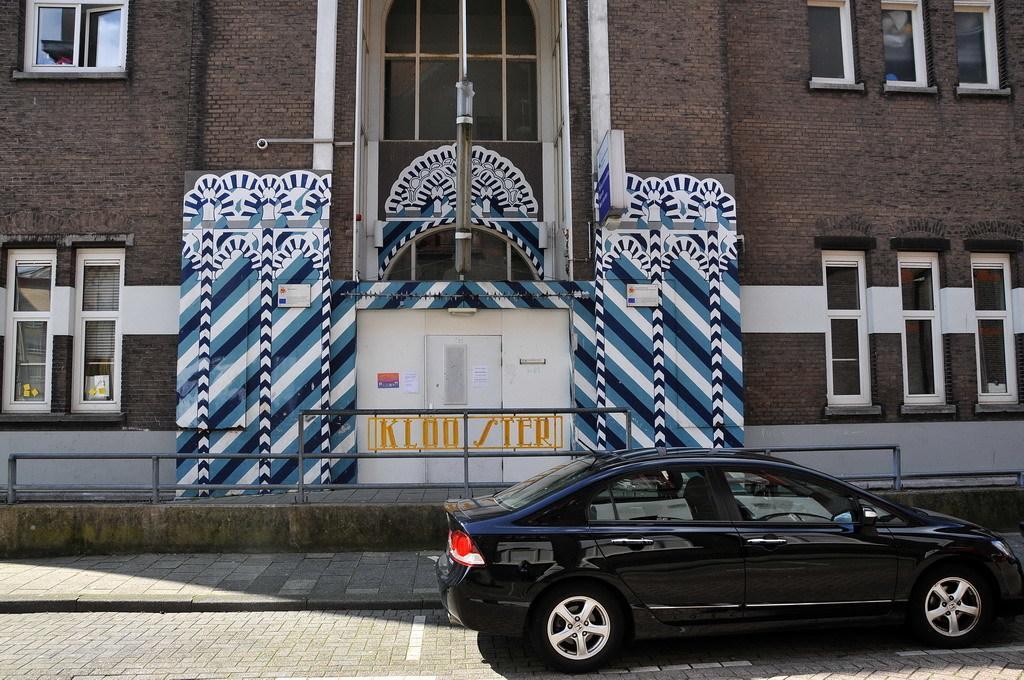Please provide a concise description of this image. In this picture we can see a black color car in the front, in the background there is a building, we can see windows and a door of this building. 